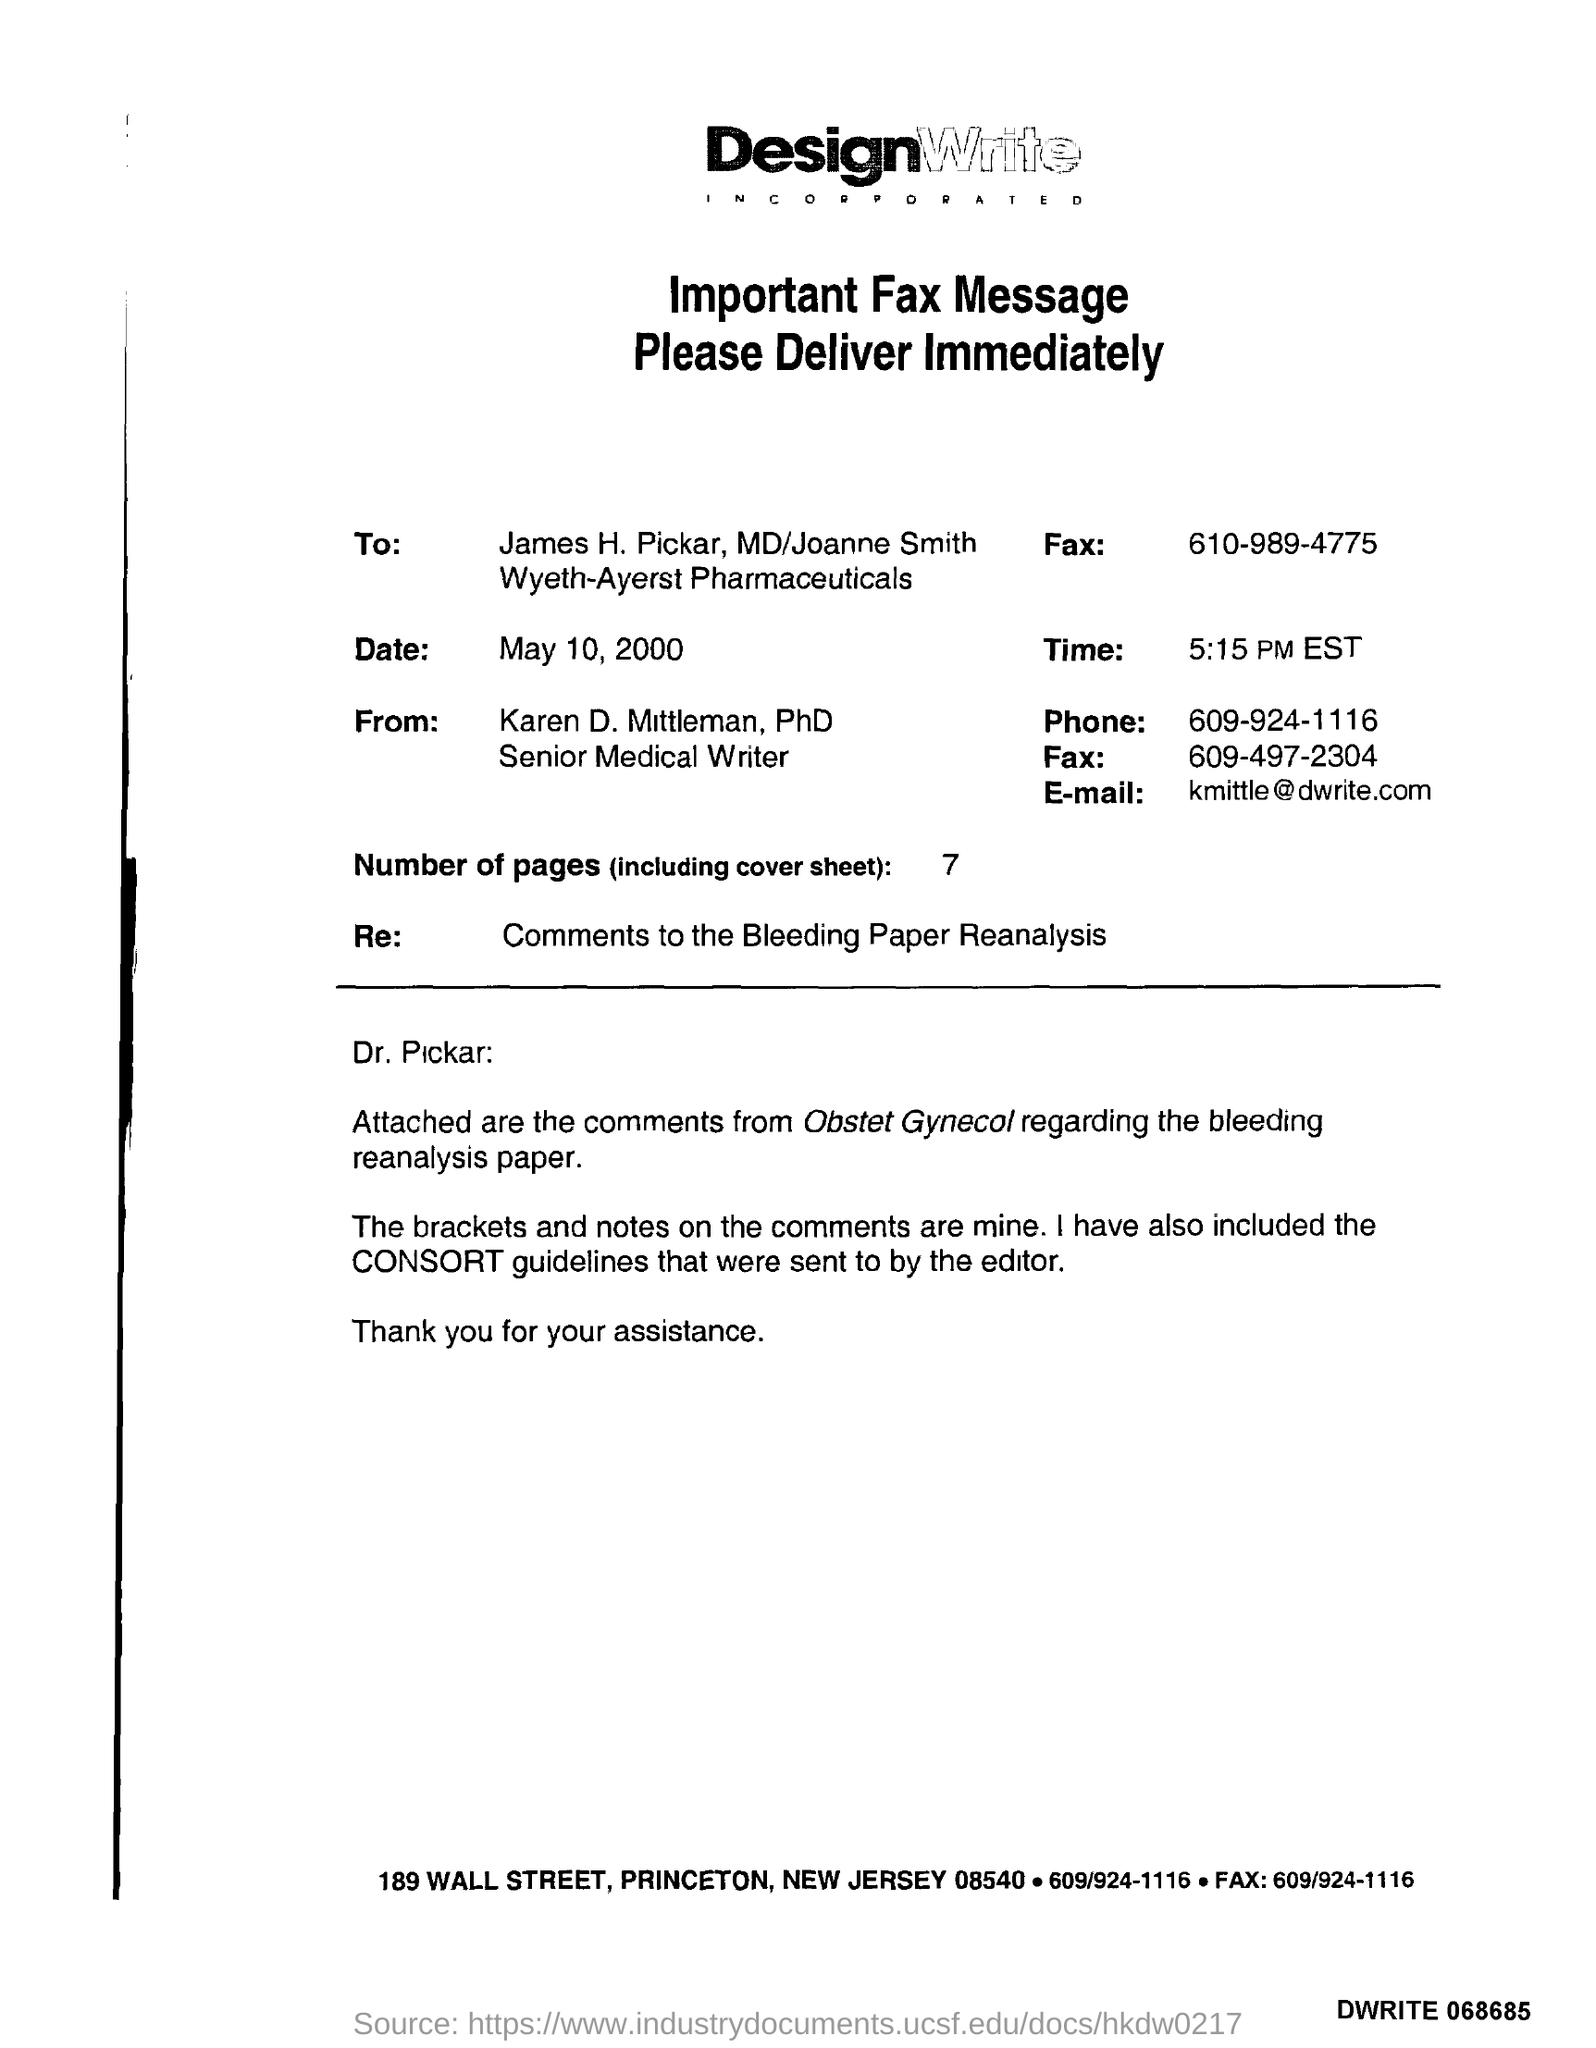Who sent consort guidelines?
Offer a terse response. The editor. 